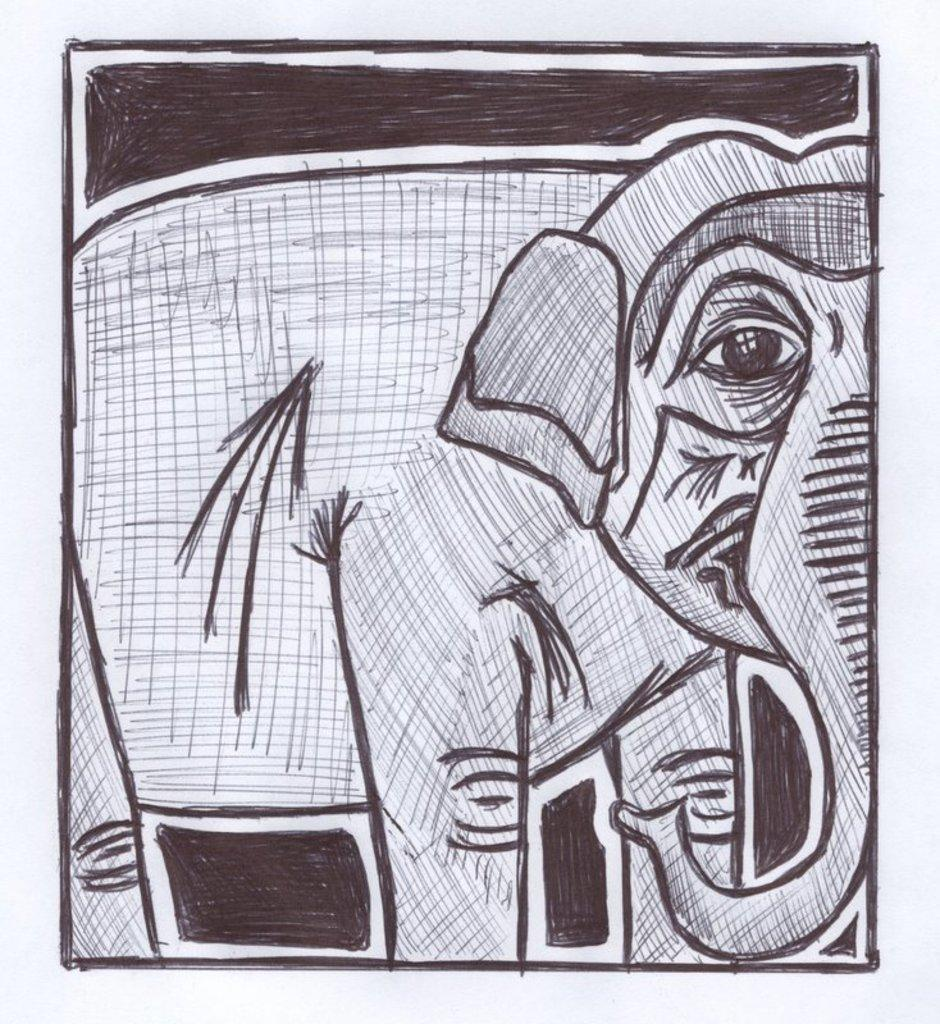What is depicted in the image? There is a drawing of an elephant in the image. What type of voice does the elephant have in the image? The image is a drawing of an elephant, and drawings do not have voices. 